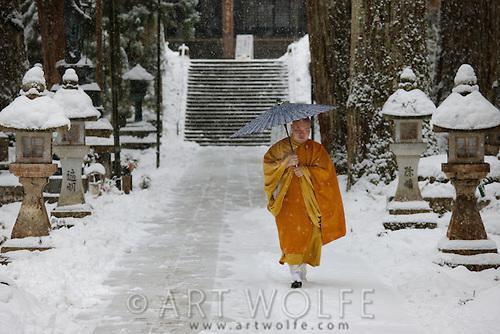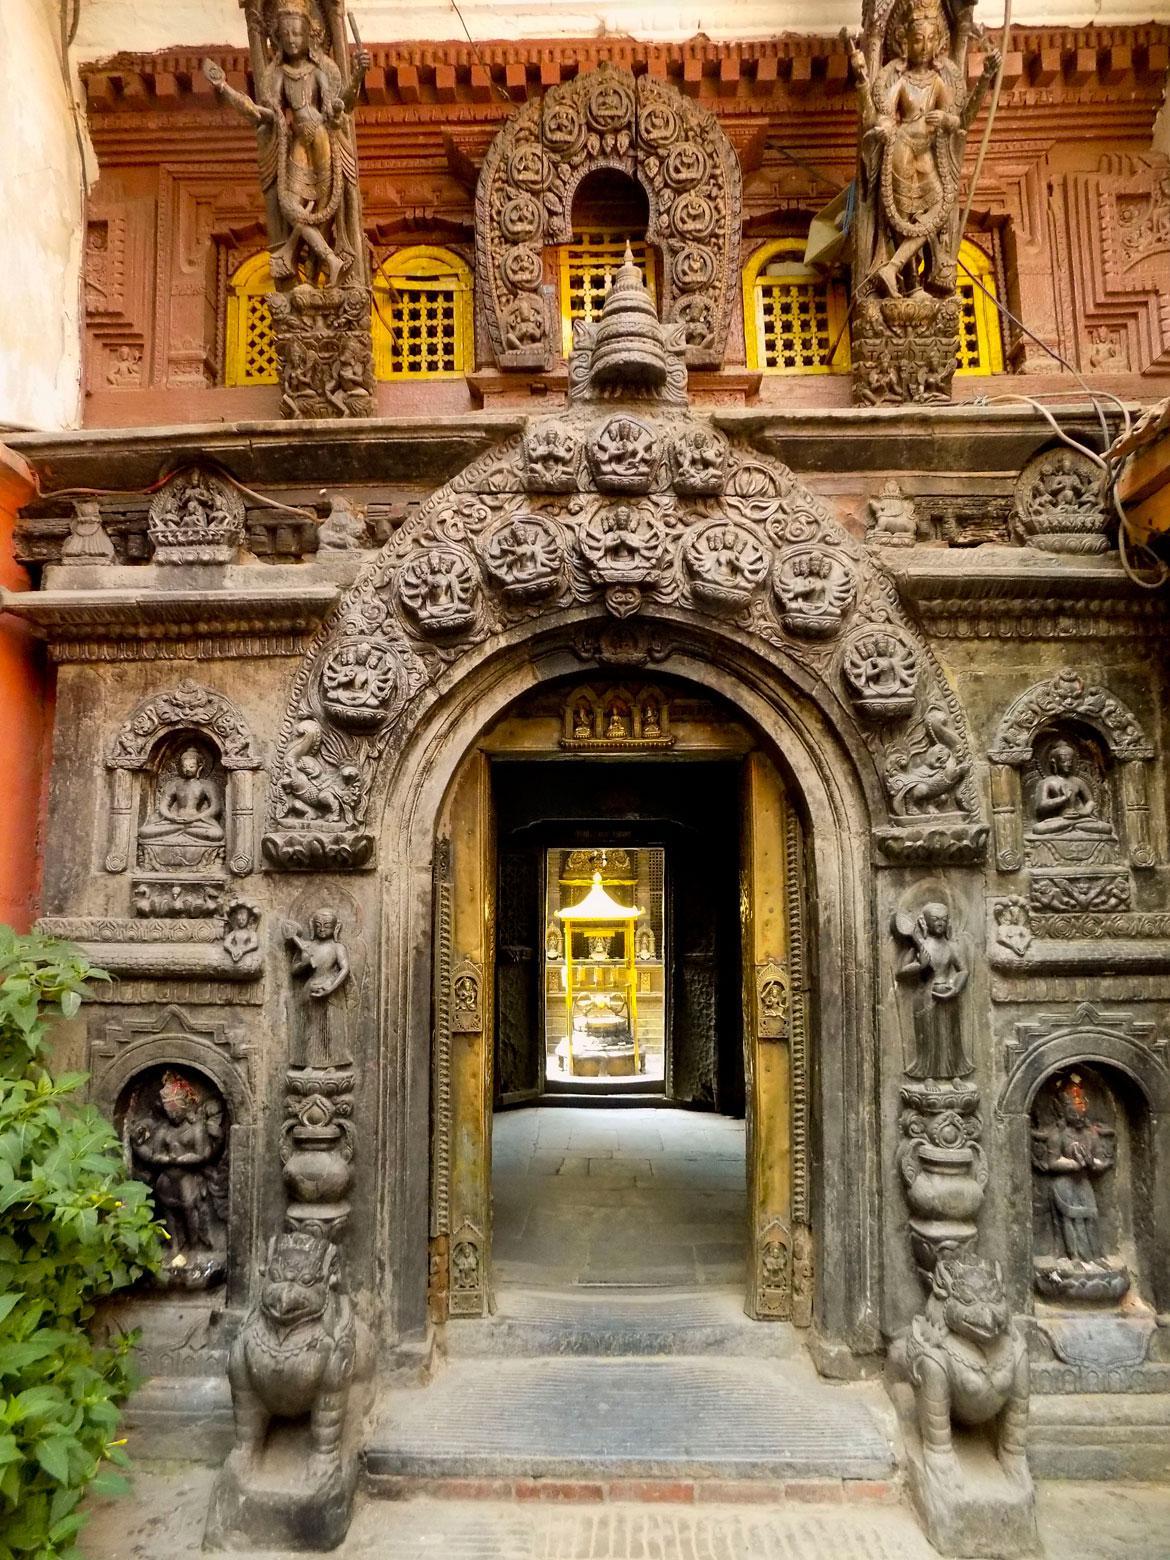The first image is the image on the left, the second image is the image on the right. Examine the images to the left and right. Is the description "One photo shows one or more monks with yellow robes and an umbrella." accurate? Answer yes or no. Yes. The first image is the image on the left, the second image is the image on the right. Considering the images on both sides, is "There is at least one person dressed in a yellow robe carrying an umbrella" valid? Answer yes or no. Yes. 